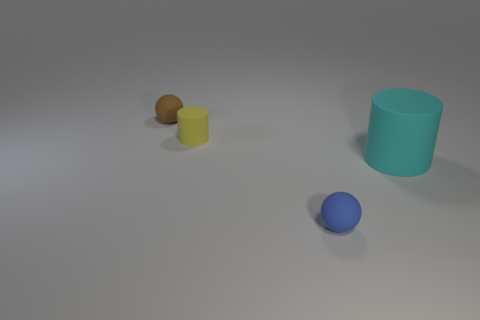How many things are yellow cylinders or rubber cylinders on the left side of the cyan matte thing?
Ensure brevity in your answer.  1. Do the yellow object and the blue sphere have the same size?
Provide a succinct answer. Yes. There is a large cyan thing; are there any rubber things behind it?
Give a very brief answer. Yes. What size is the rubber thing that is both right of the brown thing and behind the cyan thing?
Provide a succinct answer. Small. What number of objects are either tiny balls or cylinders?
Offer a very short reply. 4. Is the size of the cyan matte cylinder the same as the sphere that is in front of the brown sphere?
Ensure brevity in your answer.  No. There is a thing that is right of the matte ball that is in front of the cylinder that is on the left side of the big matte thing; what is its size?
Provide a short and direct response. Large. Are any big metallic balls visible?
Your answer should be compact. No. How many things are either large cyan things in front of the yellow rubber cylinder or blue rubber objects on the right side of the small brown rubber object?
Your answer should be compact. 2. How many tiny yellow objects are to the left of the rubber sphere that is right of the small brown matte object?
Provide a short and direct response. 1. 